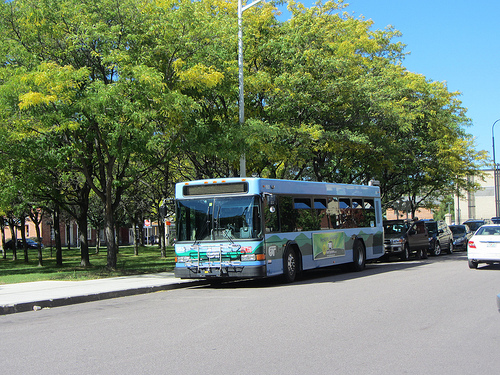What type of transportation is visible in the image? The transportation visible in the image is a bus. Can you describe the surroundings of the bus in detail? The surroundings of the bus include a clear blue sky overhead, lush green trees providing ample shade, a sidewalk to the left which is light in color, and a streetlight behind the bus. There are also multiple cars parked along the right side of the road. 